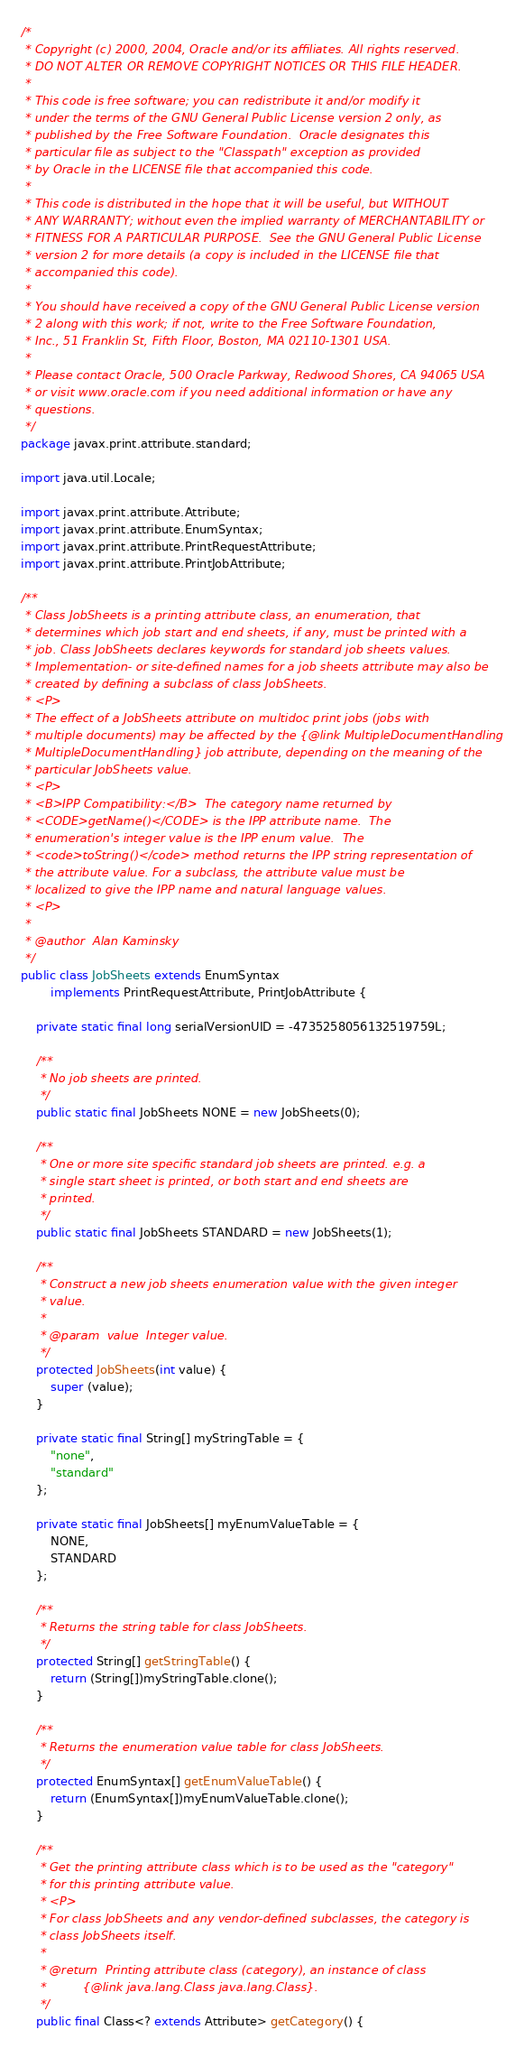<code> <loc_0><loc_0><loc_500><loc_500><_Java_>/*
 * Copyright (c) 2000, 2004, Oracle and/or its affiliates. All rights reserved.
 * DO NOT ALTER OR REMOVE COPYRIGHT NOTICES OR THIS FILE HEADER.
 *
 * This code is free software; you can redistribute it and/or modify it
 * under the terms of the GNU General Public License version 2 only, as
 * published by the Free Software Foundation.  Oracle designates this
 * particular file as subject to the "Classpath" exception as provided
 * by Oracle in the LICENSE file that accompanied this code.
 *
 * This code is distributed in the hope that it will be useful, but WITHOUT
 * ANY WARRANTY; without even the implied warranty of MERCHANTABILITY or
 * FITNESS FOR A PARTICULAR PURPOSE.  See the GNU General Public License
 * version 2 for more details (a copy is included in the LICENSE file that
 * accompanied this code).
 *
 * You should have received a copy of the GNU General Public License version
 * 2 along with this work; if not, write to the Free Software Foundation,
 * Inc., 51 Franklin St, Fifth Floor, Boston, MA 02110-1301 USA.
 *
 * Please contact Oracle, 500 Oracle Parkway, Redwood Shores, CA 94065 USA
 * or visit www.oracle.com if you need additional information or have any
 * questions.
 */
package javax.print.attribute.standard;

import java.util.Locale;

import javax.print.attribute.Attribute;
import javax.print.attribute.EnumSyntax;
import javax.print.attribute.PrintRequestAttribute;
import javax.print.attribute.PrintJobAttribute;

/**
 * Class JobSheets is a printing attribute class, an enumeration, that
 * determines which job start and end sheets, if any, must be printed with a
 * job. Class JobSheets declares keywords for standard job sheets values.
 * Implementation- or site-defined names for a job sheets attribute may also be
 * created by defining a subclass of class JobSheets.
 * <P>
 * The effect of a JobSheets attribute on multidoc print jobs (jobs with
 * multiple documents) may be affected by the {@link MultipleDocumentHandling
 * MultipleDocumentHandling} job attribute, depending on the meaning of the
 * particular JobSheets value.
 * <P>
 * <B>IPP Compatibility:</B>  The category name returned by
 * <CODE>getName()</CODE> is the IPP attribute name.  The
 * enumeration's integer value is the IPP enum value.  The
 * <code>toString()</code> method returns the IPP string representation of
 * the attribute value. For a subclass, the attribute value must be
 * localized to give the IPP name and natural language values.
 * <P>
 *
 * @author  Alan Kaminsky
 */
public class JobSheets extends EnumSyntax
        implements PrintRequestAttribute, PrintJobAttribute {

    private static final long serialVersionUID = -4735258056132519759L;

    /**
     * No job sheets are printed.
     */
    public static final JobSheets NONE = new JobSheets(0);

    /**
     * One or more site specific standard job sheets are printed. e.g. a
     * single start sheet is printed, or both start and end sheets are
     * printed.
     */
    public static final JobSheets STANDARD = new JobSheets(1);

    /**
     * Construct a new job sheets enumeration value with the given integer
     * value.
     *
     * @param  value  Integer value.
     */
    protected JobSheets(int value) {
        super (value);
    }

    private static final String[] myStringTable = {
        "none",
        "standard"
    };

    private static final JobSheets[] myEnumValueTable = {
        NONE,
        STANDARD
    };

    /**
     * Returns the string table for class JobSheets.
     */
    protected String[] getStringTable() {
        return (String[])myStringTable.clone();
    }

    /**
     * Returns the enumeration value table for class JobSheets.
     */
    protected EnumSyntax[] getEnumValueTable() {
        return (EnumSyntax[])myEnumValueTable.clone();
    }

    /**
     * Get the printing attribute class which is to be used as the "category"
     * for this printing attribute value.
     * <P>
     * For class JobSheets and any vendor-defined subclasses, the category is
     * class JobSheets itself.
     *
     * @return  Printing attribute class (category), an instance of class
     *          {@link java.lang.Class java.lang.Class}.
     */
    public final Class<? extends Attribute> getCategory() {</code> 